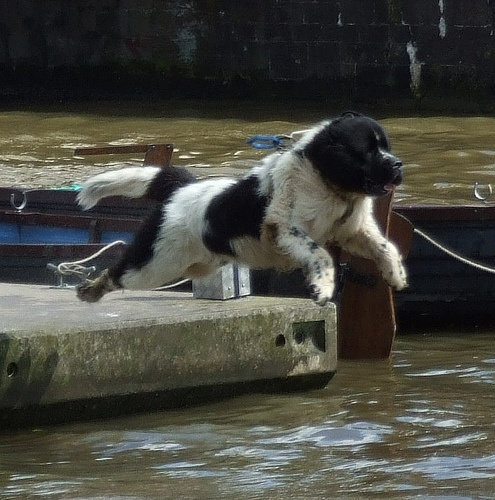Describe the objects in this image and their specific colors. I can see dog in black, gray, darkgray, and lightgray tones, boat in black, gray, navy, and darkblue tones, and boat in black, gray, darkgray, and lightgray tones in this image. 